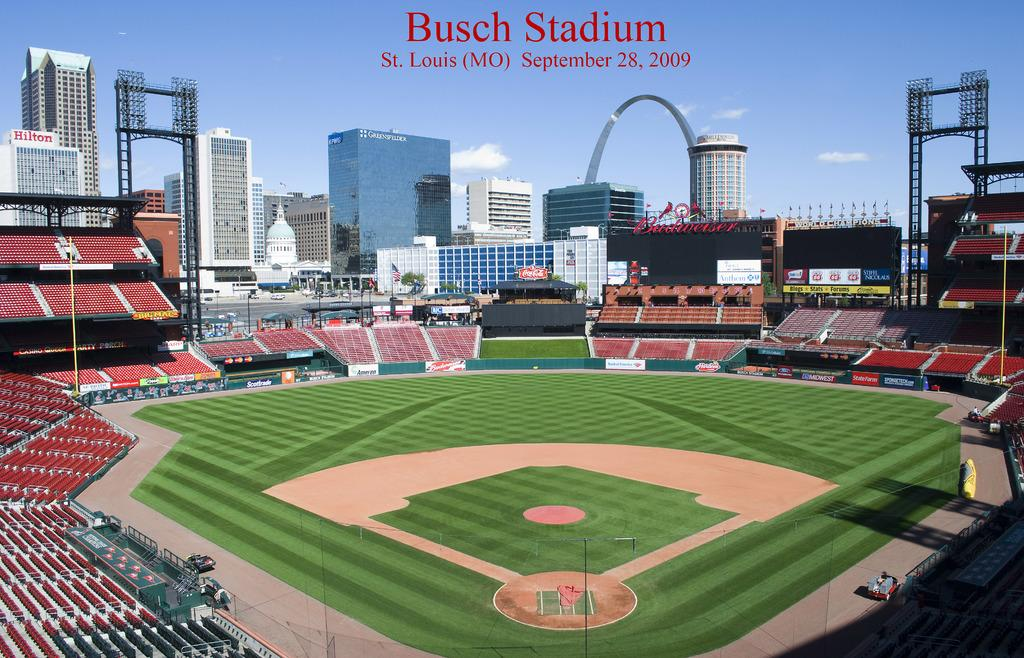<image>
Present a compact description of the photo's key features. A baseball stadium that says  Busch Stadium  St Louis (MO) September 28,2009 